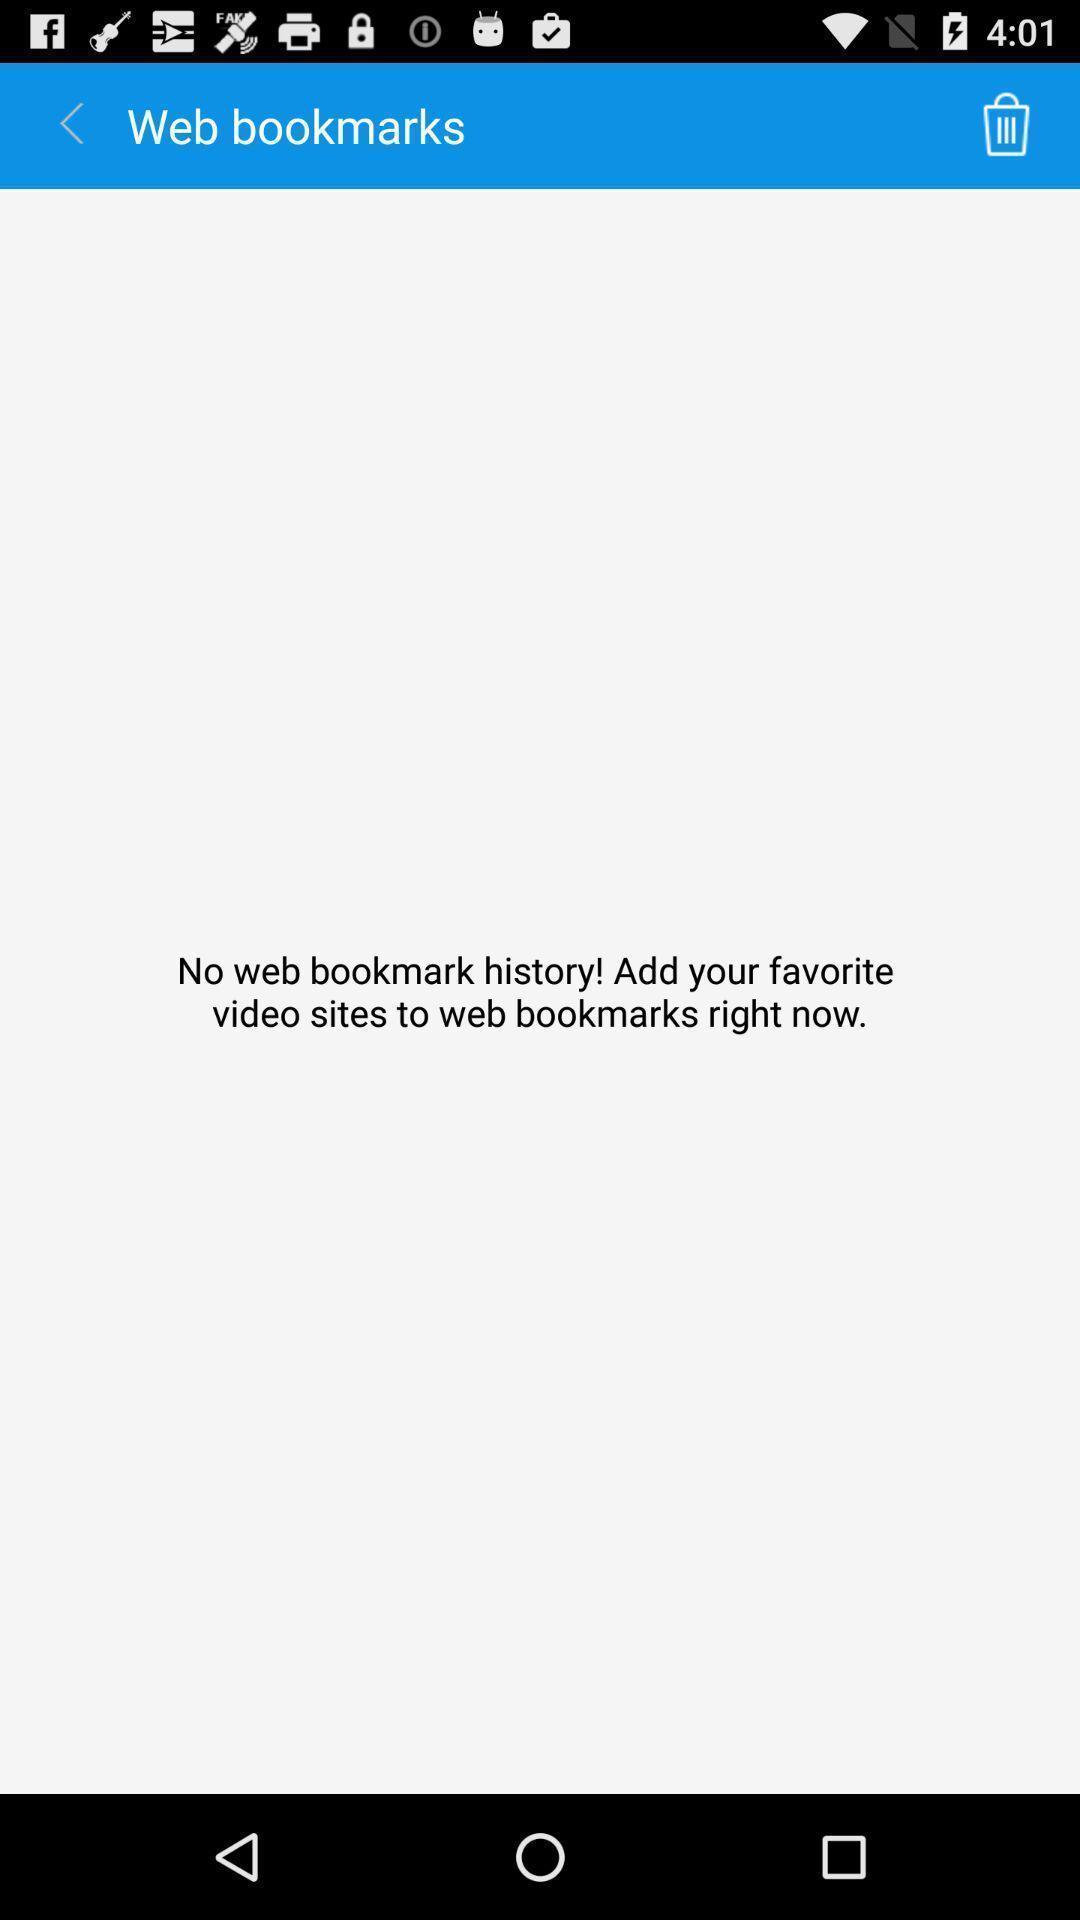Give me a narrative description of this picture. Page showing no bookmarks on video downloading web. 